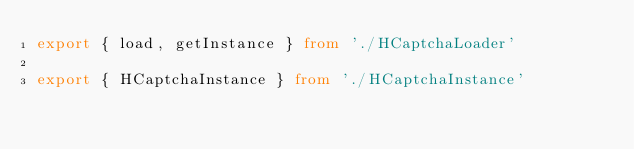<code> <loc_0><loc_0><loc_500><loc_500><_TypeScript_>export { load, getInstance } from './HCaptchaLoader'

export { HCaptchaInstance } from './HCaptchaInstance'
</code> 